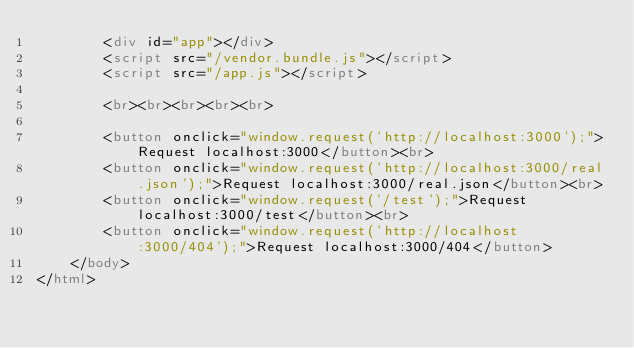<code> <loc_0><loc_0><loc_500><loc_500><_HTML_>        <div id="app"></div>
        <script src="/vendor.bundle.js"></script>
        <script src="/app.js"></script>

        <br><br><br><br><br>

        <button onclick="window.request('http://localhost:3000');">Request localhost:3000</button><br>
        <button onclick="window.request('http://localhost:3000/real.json');">Request localhost:3000/real.json</button><br>
        <button onclick="window.request('/test');">Request localhost:3000/test</button><br>
        <button onclick="window.request('http://localhost:3000/404');">Request localhost:3000/404</button>
    </body>
</html></code> 